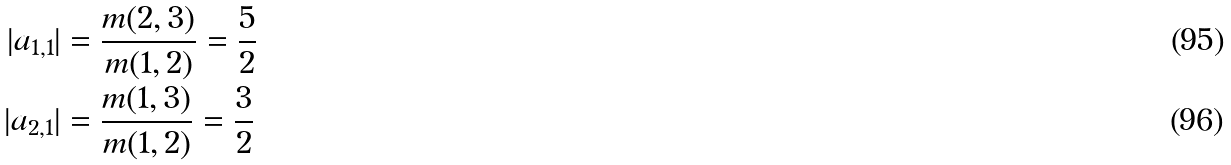<formula> <loc_0><loc_0><loc_500><loc_500>| a _ { 1 , 1 } | & = \frac { m ( 2 , 3 ) } { m ( 1 , 2 ) } = \frac { 5 } { 2 } \\ | a _ { 2 , 1 } | & = \frac { m ( 1 , 3 ) } { m ( 1 , 2 ) } = \frac { 3 } { 2 }</formula> 